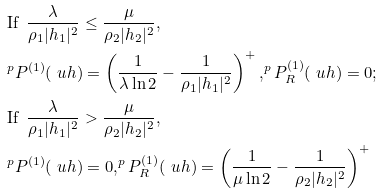<formula> <loc_0><loc_0><loc_500><loc_500>& \text {If } \, \frac { \lambda } { \rho _ { 1 } | h _ { 1 } | ^ { 2 } } \leq \frac { \mu } { \rho _ { 2 } | h _ { 2 } | ^ { 2 } } , \\ & ^ { p } P ^ { ( 1 ) } ( \ u h ) = \left ( \frac { 1 } { \lambda \ln 2 } - \frac { 1 } { \rho _ { 1 } | h _ { 1 } | ^ { 2 } } \right ) ^ { + } , ^ { p } P _ { R } ^ { ( 1 ) } ( \ u h ) = 0 ; \\ & \text {If } \, \frac { \lambda } { \rho _ { 1 } | h _ { 1 } | ^ { 2 } } > \frac { \mu } { \rho _ { 2 } | h _ { 2 } | ^ { 2 } } , \\ & ^ { p } P ^ { ( 1 ) } ( \ u h ) = 0 , ^ { p } P _ { R } ^ { ( 1 ) } ( \ u h ) = \left ( \frac { 1 } { \mu \ln 2 } - \frac { 1 } { \rho _ { 2 } | h _ { 2 } | ^ { 2 } } \right ) ^ { + }</formula> 